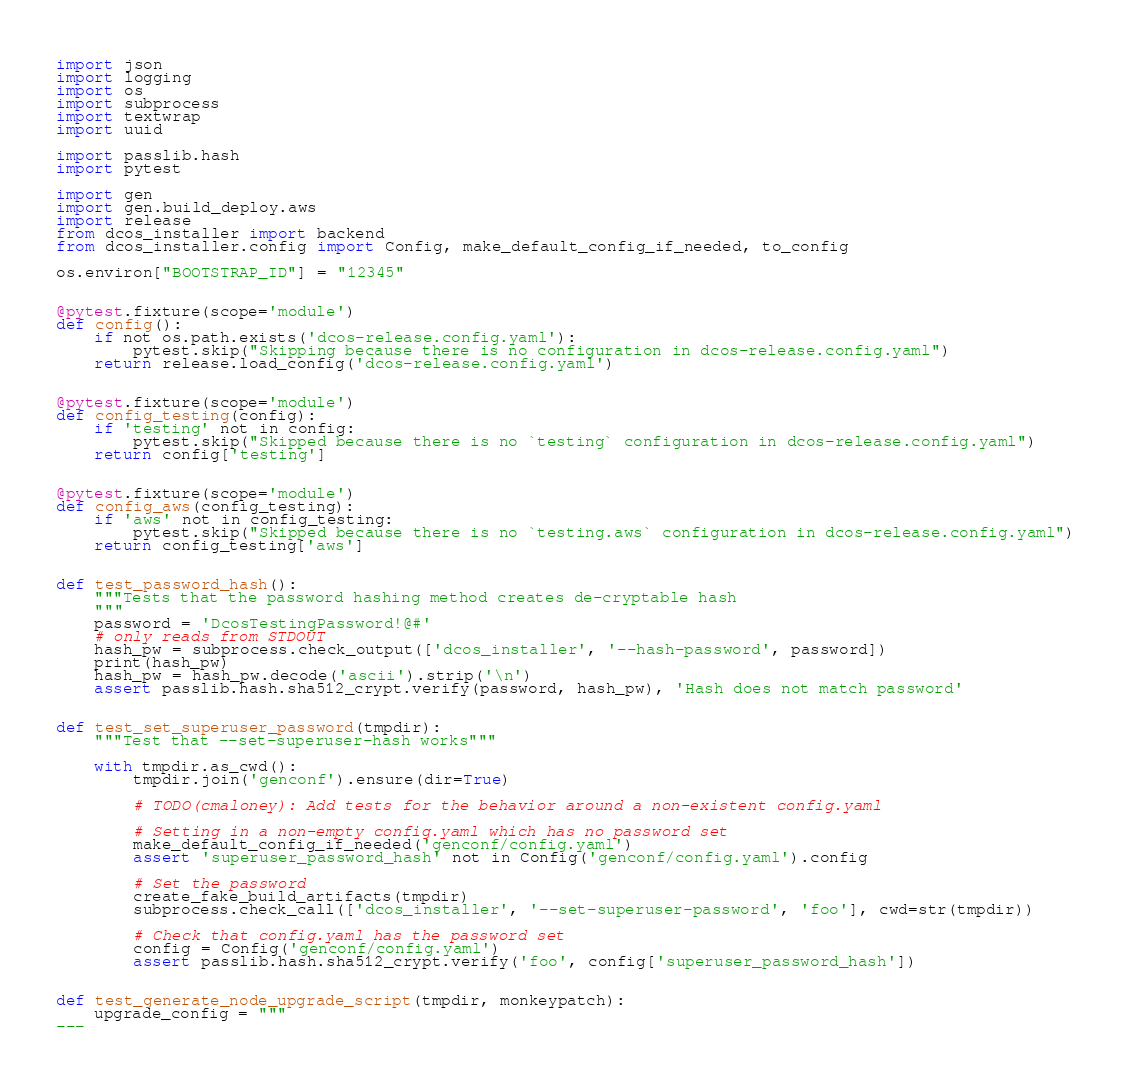<code> <loc_0><loc_0><loc_500><loc_500><_Python_>import json
import logging
import os
import subprocess
import textwrap
import uuid

import passlib.hash
import pytest

import gen
import gen.build_deploy.aws
import release
from dcos_installer import backend
from dcos_installer.config import Config, make_default_config_if_needed, to_config

os.environ["BOOTSTRAP_ID"] = "12345"


@pytest.fixture(scope='module')
def config():
    if not os.path.exists('dcos-release.config.yaml'):
        pytest.skip("Skipping because there is no configuration in dcos-release.config.yaml")
    return release.load_config('dcos-release.config.yaml')


@pytest.fixture(scope='module')
def config_testing(config):
    if 'testing' not in config:
        pytest.skip("Skipped because there is no `testing` configuration in dcos-release.config.yaml")
    return config['testing']


@pytest.fixture(scope='module')
def config_aws(config_testing):
    if 'aws' not in config_testing:
        pytest.skip("Skipped because there is no `testing.aws` configuration in dcos-release.config.yaml")
    return config_testing['aws']


def test_password_hash():
    """Tests that the password hashing method creates de-cryptable hash
    """
    password = 'DcosTestingPassword!@#'
    # only reads from STDOUT
    hash_pw = subprocess.check_output(['dcos_installer', '--hash-password', password])
    print(hash_pw)
    hash_pw = hash_pw.decode('ascii').strip('\n')
    assert passlib.hash.sha512_crypt.verify(password, hash_pw), 'Hash does not match password'


def test_set_superuser_password(tmpdir):
    """Test that --set-superuser-hash works"""

    with tmpdir.as_cwd():
        tmpdir.join('genconf').ensure(dir=True)

        # TODO(cmaloney): Add tests for the behavior around a non-existent config.yaml

        # Setting in a non-empty config.yaml which has no password set
        make_default_config_if_needed('genconf/config.yaml')
        assert 'superuser_password_hash' not in Config('genconf/config.yaml').config

        # Set the password
        create_fake_build_artifacts(tmpdir)
        subprocess.check_call(['dcos_installer', '--set-superuser-password', 'foo'], cwd=str(tmpdir))

        # Check that config.yaml has the password set
        config = Config('genconf/config.yaml')
        assert passlib.hash.sha512_crypt.verify('foo', config['superuser_password_hash'])


def test_generate_node_upgrade_script(tmpdir, monkeypatch):
    upgrade_config = """
---</code> 